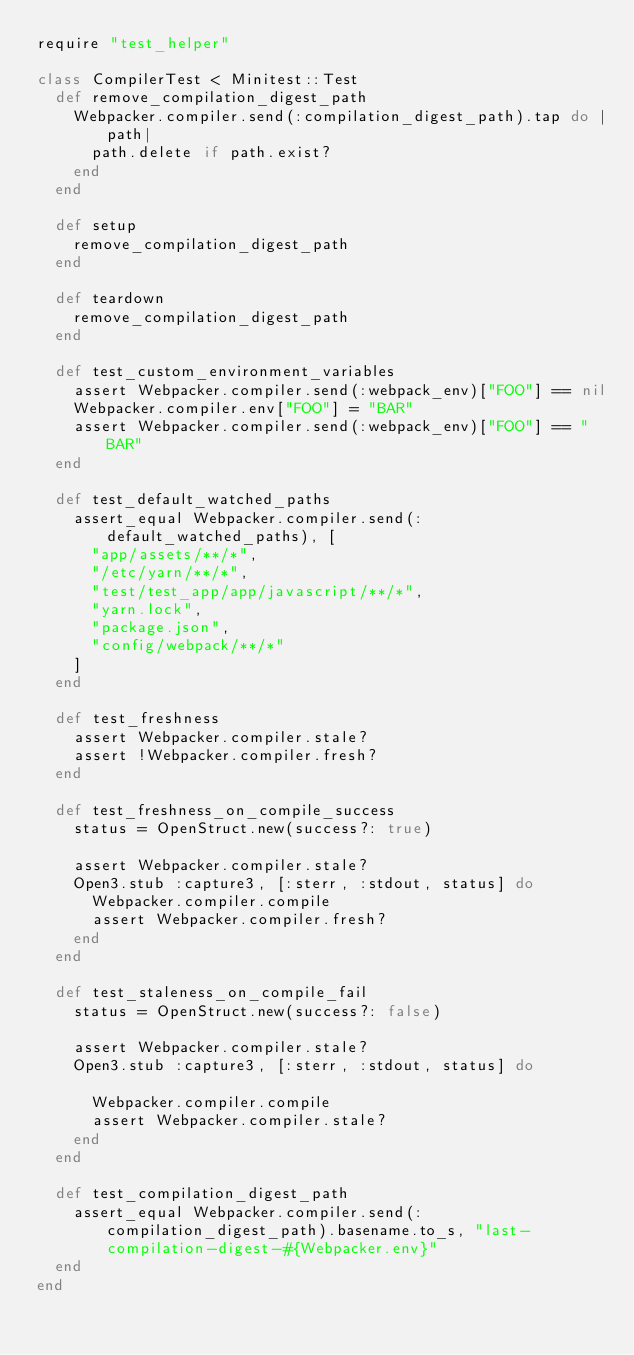Convert code to text. <code><loc_0><loc_0><loc_500><loc_500><_Ruby_>require "test_helper"

class CompilerTest < Minitest::Test
  def remove_compilation_digest_path
    Webpacker.compiler.send(:compilation_digest_path).tap do |path|
      path.delete if path.exist?
    end
  end

  def setup
    remove_compilation_digest_path
  end

  def teardown
    remove_compilation_digest_path
  end

  def test_custom_environment_variables
    assert Webpacker.compiler.send(:webpack_env)["FOO"] == nil
    Webpacker.compiler.env["FOO"] = "BAR"
    assert Webpacker.compiler.send(:webpack_env)["FOO"] == "BAR"
  end

  def test_default_watched_paths
    assert_equal Webpacker.compiler.send(:default_watched_paths), [
      "app/assets/**/*",
      "/etc/yarn/**/*",
      "test/test_app/app/javascript/**/*",
      "yarn.lock",
      "package.json",
      "config/webpack/**/*"
    ]
  end

  def test_freshness
    assert Webpacker.compiler.stale?
    assert !Webpacker.compiler.fresh?
  end

  def test_freshness_on_compile_success
    status = OpenStruct.new(success?: true)

    assert Webpacker.compiler.stale?
    Open3.stub :capture3, [:sterr, :stdout, status] do
      Webpacker.compiler.compile
      assert Webpacker.compiler.fresh?
    end
  end

  def test_staleness_on_compile_fail
    status = OpenStruct.new(success?: false)

    assert Webpacker.compiler.stale?
    Open3.stub :capture3, [:sterr, :stdout, status] do

      Webpacker.compiler.compile
      assert Webpacker.compiler.stale?
    end
  end

  def test_compilation_digest_path
    assert_equal Webpacker.compiler.send(:compilation_digest_path).basename.to_s, "last-compilation-digest-#{Webpacker.env}"
  end
end
</code> 